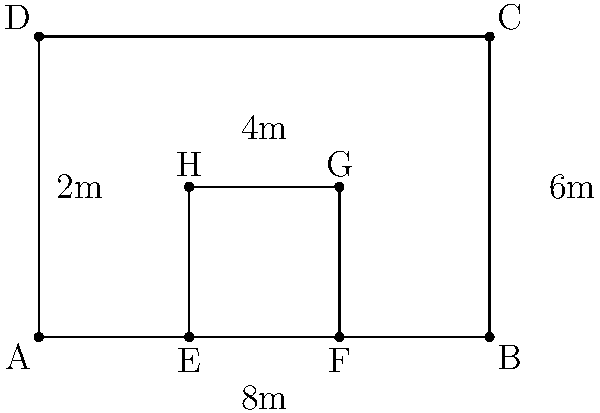As a military officer, you need to calculate the area of camouflage required to cover a rectangular piece of equipment with a rectangular cutout. The outer rectangle measures 8m by 6m, while the inner cutout measures 2m by 2m. What is the total area of camouflage needed? To calculate the area of camouflage needed, we'll follow these steps:

1. Calculate the area of the outer rectangle:
   $A_{outer} = length \times width = 8m \times 6m = 48m^2$

2. Calculate the area of the inner cutout:
   $A_{inner} = length \times width = 2m \times 2m = 4m^2$

3. Subtract the area of the inner cutout from the outer rectangle:
   $A_{camouflage} = A_{outer} - A_{inner} = 48m^2 - 4m^2 = 44m^2$

Therefore, the total area of camouflage needed is $44m^2$.
Answer: $44m^2$ 